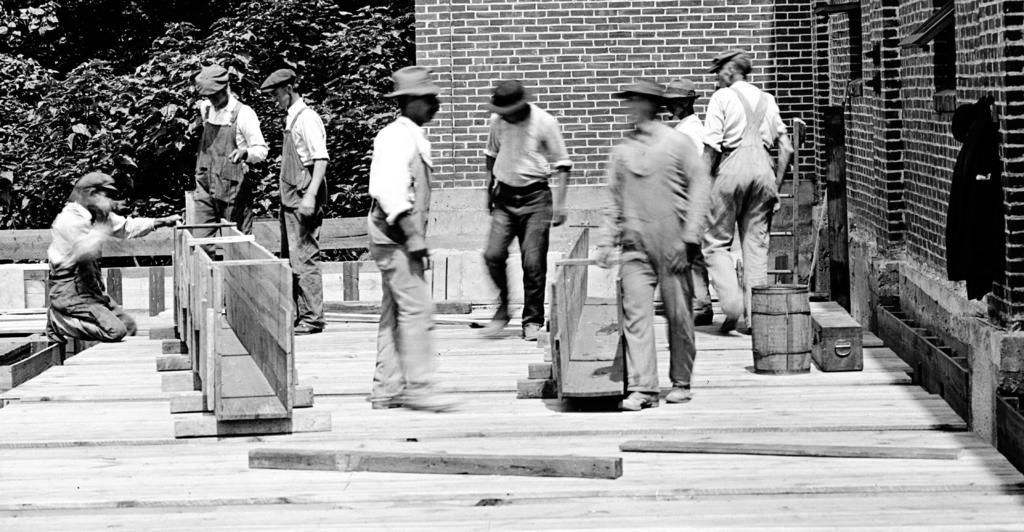What is the color scheme of the image? The image is black and white. What are the people in the image doing? The workers in the image are working on a wooden object. What can be seen in the background of the image? There are trees and walls in the background of the image. What type of rings are the workers wearing in the image? There are no rings visible on the workers in the image. What kind of pleasure can be seen on the workers' faces in the image? The image is black and white and does not show the workers' facial expressions, so it is not possible to determine their level of pleasure. 